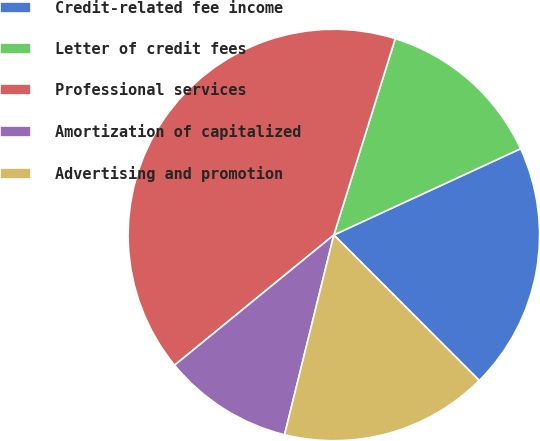Convert chart to OTSL. <chart><loc_0><loc_0><loc_500><loc_500><pie_chart><fcel>Credit-related fee income<fcel>Letter of credit fees<fcel>Professional services<fcel>Amortization of capitalized<fcel>Advertising and promotion<nl><fcel>19.39%<fcel>13.29%<fcel>40.73%<fcel>10.24%<fcel>16.34%<nl></chart> 